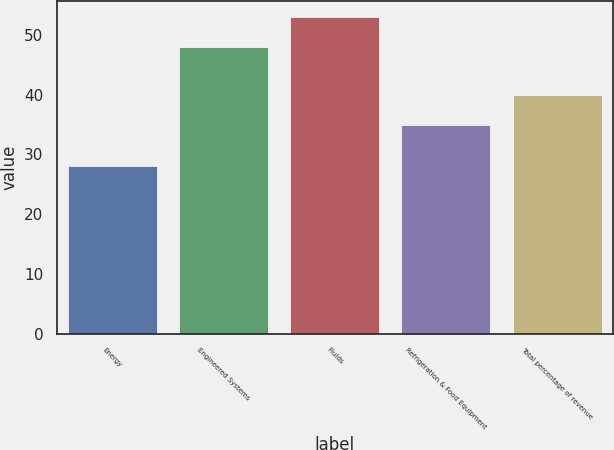Convert chart. <chart><loc_0><loc_0><loc_500><loc_500><bar_chart><fcel>Energy<fcel>Engineered Systems<fcel>Fluids<fcel>Refrigeration & Food Equipment<fcel>Total percentage of revenue<nl><fcel>28<fcel>48<fcel>53<fcel>35<fcel>40<nl></chart> 